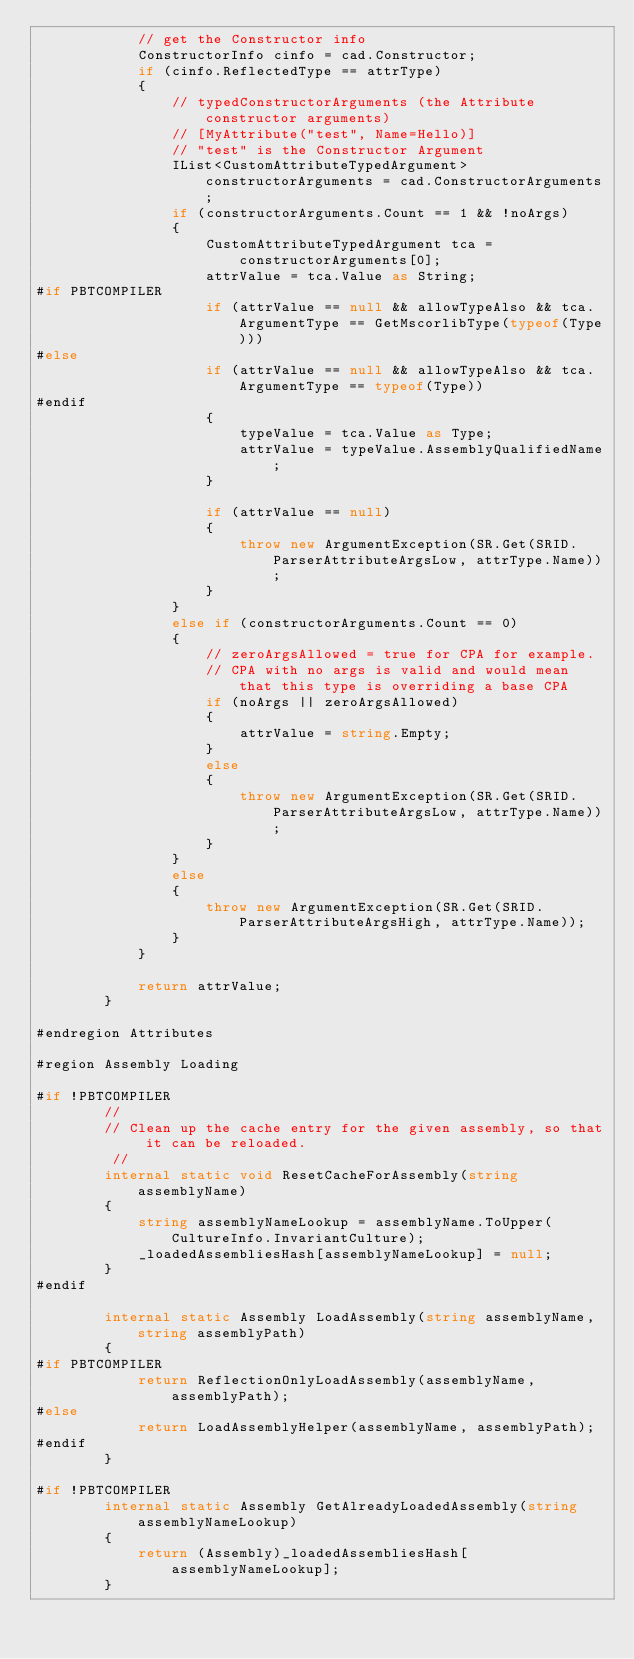Convert code to text. <code><loc_0><loc_0><loc_500><loc_500><_C#_>            // get the Constructor info
            ConstructorInfo cinfo = cad.Constructor;
            if (cinfo.ReflectedType == attrType)
            {
                // typedConstructorArguments (the Attribute constructor arguments)
                // [MyAttribute("test", Name=Hello)]
                // "test" is the Constructor Argument
                IList<CustomAttributeTypedArgument> constructorArguments = cad.ConstructorArguments;
                if (constructorArguments.Count == 1 && !noArgs)
                {
                    CustomAttributeTypedArgument tca = constructorArguments[0];
                    attrValue = tca.Value as String;
#if PBTCOMPILER
                    if (attrValue == null && allowTypeAlso && tca.ArgumentType == GetMscorlibType(typeof(Type)))
#else
                    if (attrValue == null && allowTypeAlso && tca.ArgumentType == typeof(Type))
#endif
                    {
                        typeValue = tca.Value as Type;
                        attrValue = typeValue.AssemblyQualifiedName;
                    }

                    if (attrValue == null)
                    {
                        throw new ArgumentException(SR.Get(SRID.ParserAttributeArgsLow, attrType.Name));
                    }
                }
                else if (constructorArguments.Count == 0)
                {
                    // zeroArgsAllowed = true for CPA for example.
                    // CPA with no args is valid and would mean that this type is overriding a base CPA
                    if (noArgs || zeroArgsAllowed)
                    {
                        attrValue = string.Empty;
                    }
                    else
                    {
                        throw new ArgumentException(SR.Get(SRID.ParserAttributeArgsLow, attrType.Name));
                    }
                }
                else
                {
                    throw new ArgumentException(SR.Get(SRID.ParserAttributeArgsHigh, attrType.Name));
                }
            }

            return attrValue;
        }

#endregion Attributes

#region Assembly Loading

#if !PBTCOMPILER
        //
        // Clean up the cache entry for the given assembly, so that it can be reloaded.
         //
        internal static void ResetCacheForAssembly(string assemblyName)
        {
            string assemblyNameLookup = assemblyName.ToUpper(CultureInfo.InvariantCulture);
            _loadedAssembliesHash[assemblyNameLookup] = null;
        }
#endif

        internal static Assembly LoadAssembly(string assemblyName, string assemblyPath)
        {
#if PBTCOMPILER
            return ReflectionOnlyLoadAssembly(assemblyName, assemblyPath);
#else
            return LoadAssemblyHelper(assemblyName, assemblyPath);
#endif
        }

#if !PBTCOMPILER
        internal static Assembly GetAlreadyLoadedAssembly(string assemblyNameLookup)
        {
            return (Assembly)_loadedAssembliesHash[assemblyNameLookup];
        }
</code> 